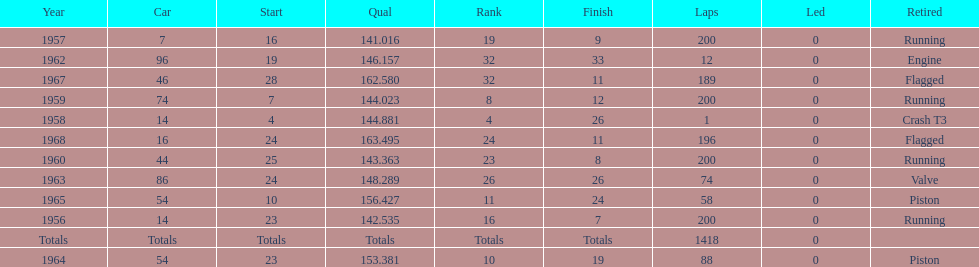Tell me the number of times he finished above 10th place. 3. 